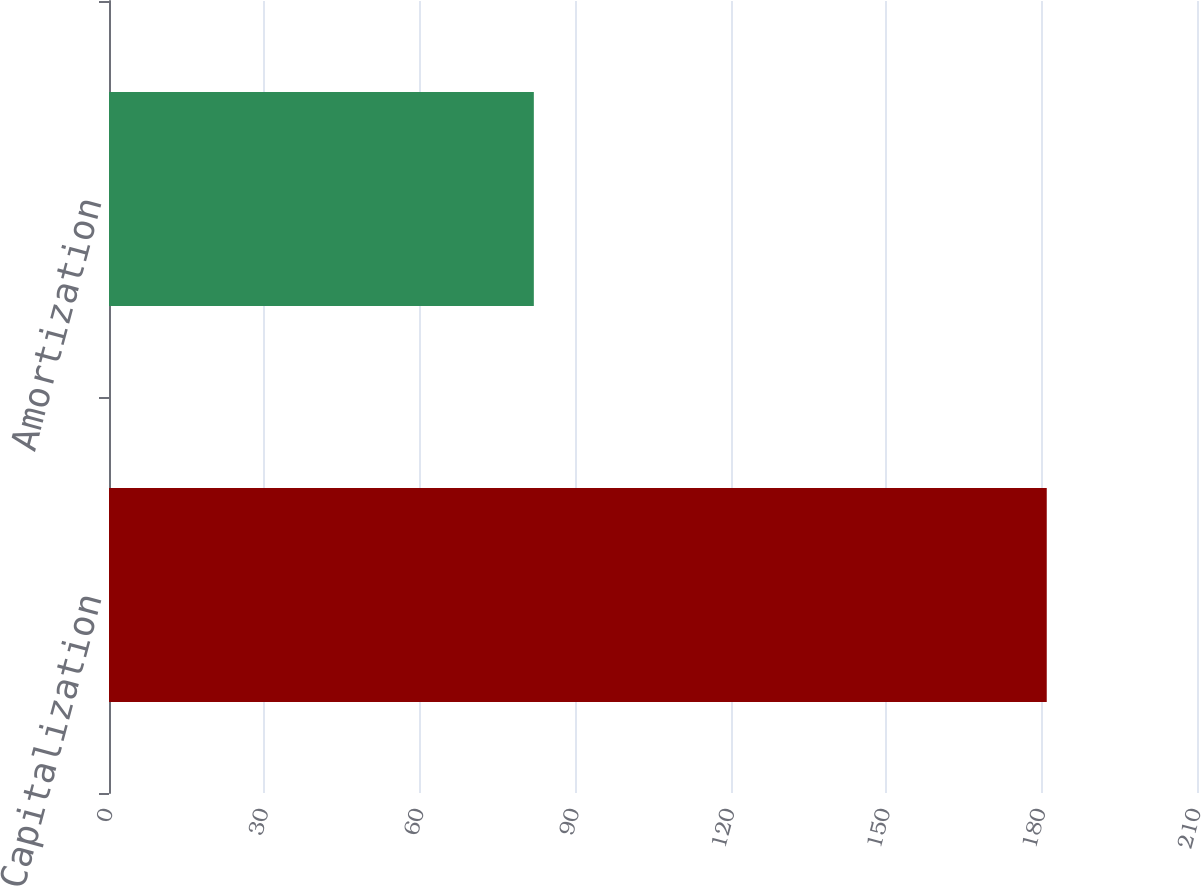Convert chart to OTSL. <chart><loc_0><loc_0><loc_500><loc_500><bar_chart><fcel>Capitalization<fcel>Amortization<nl><fcel>181<fcel>82<nl></chart> 